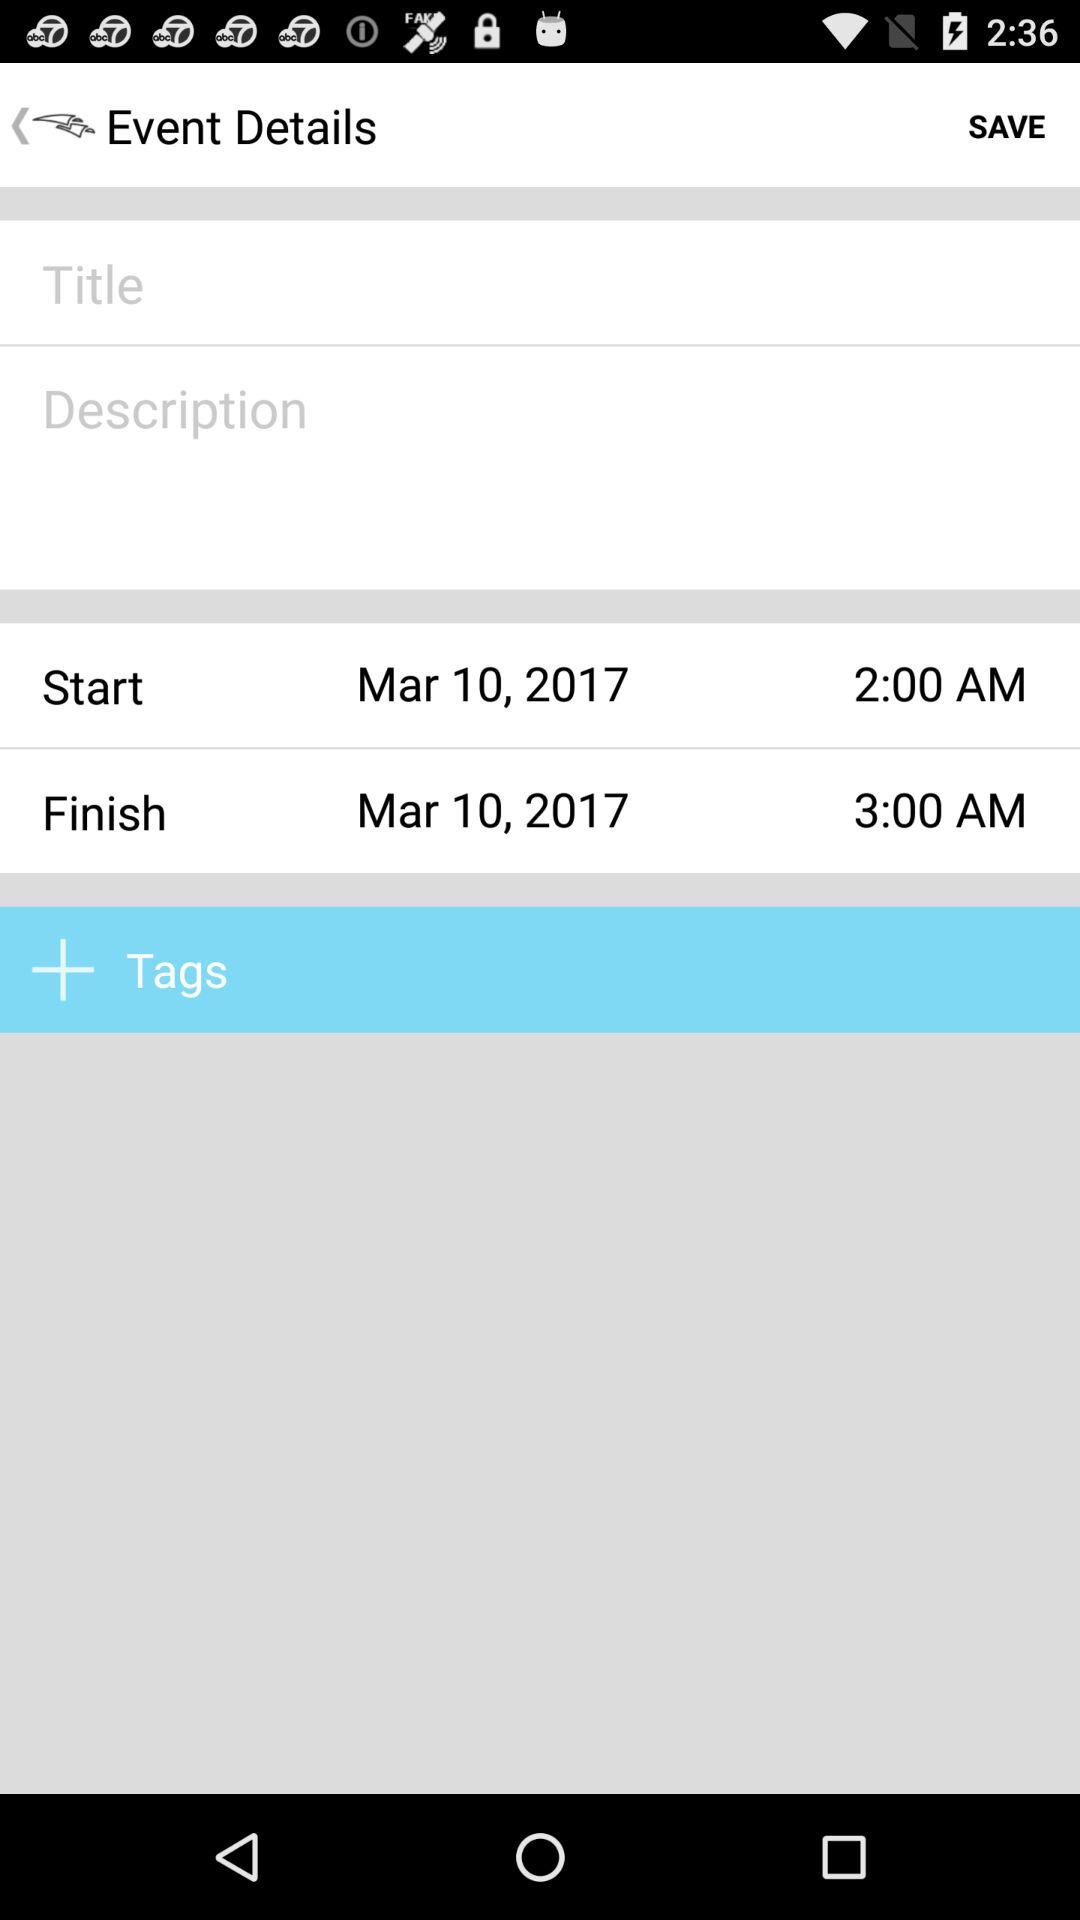What is the finish date? The finish date is March 10, 2017. 